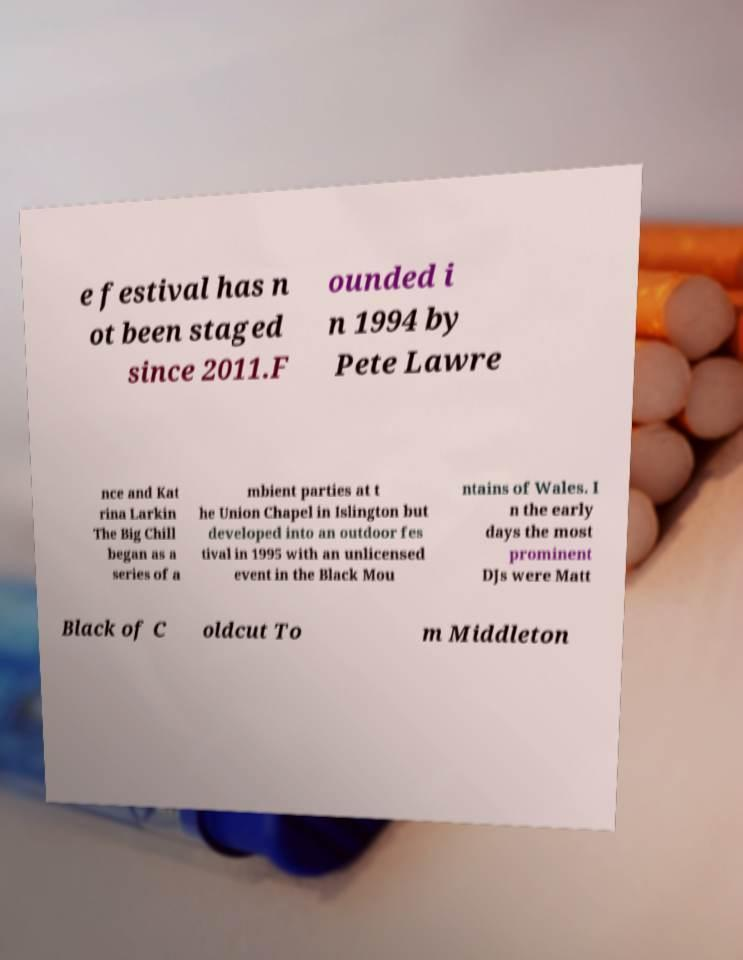Can you accurately transcribe the text from the provided image for me? e festival has n ot been staged since 2011.F ounded i n 1994 by Pete Lawre nce and Kat rina Larkin The Big Chill began as a series of a mbient parties at t he Union Chapel in Islington but developed into an outdoor fes tival in 1995 with an unlicensed event in the Black Mou ntains of Wales. I n the early days the most prominent DJs were Matt Black of C oldcut To m Middleton 